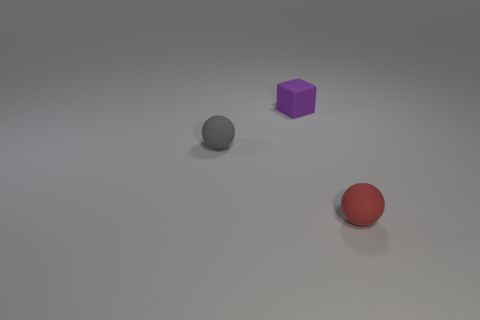How many tiny purple cubes are in front of the sphere that is right of the tiny purple object? 0 